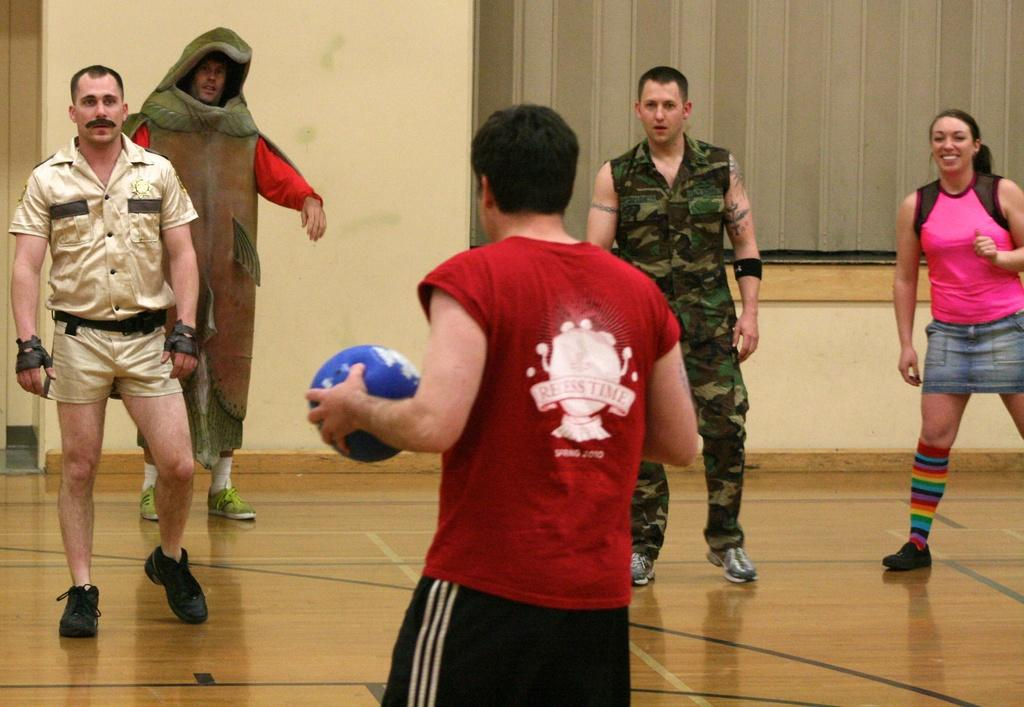What is happening in the image? There are people standing in the image. Can you describe any specific actions or objects being held by the people? Yes, there is a man holding a ball in his hand. What type of carpenter tools can be seen in the image? There are no carpenter tools present in the image. What type of comfort is provided by the people in the image? The image does not show any specific comfort being provided by the people. 